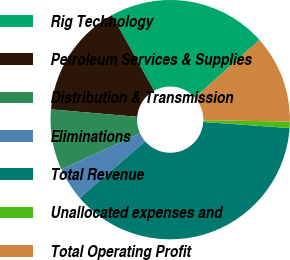<chart> <loc_0><loc_0><loc_500><loc_500><pie_chart><fcel>Rig Technology<fcel>Petroleum Services & Supplies<fcel>Distribution & Transmission<fcel>Eliminations<fcel>Total Revenue<fcel>Unallocated expenses and<fcel>Total Operating Profit<nl><fcel>21.5%<fcel>15.53%<fcel>8.2%<fcel>4.53%<fcel>37.52%<fcel>0.86%<fcel>11.86%<nl></chart> 